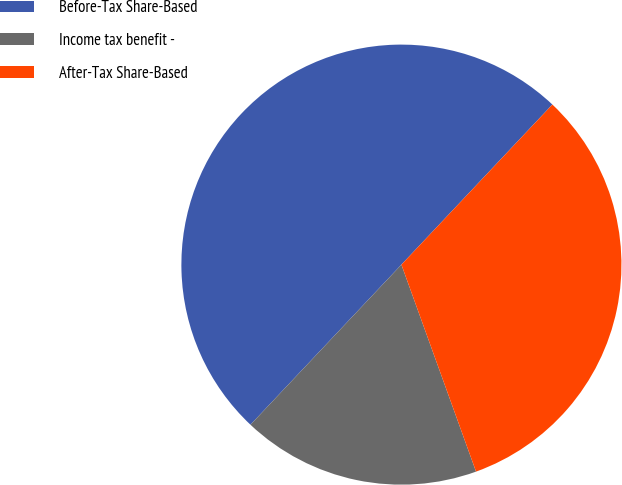Convert chart to OTSL. <chart><loc_0><loc_0><loc_500><loc_500><pie_chart><fcel>Before-Tax Share-Based<fcel>Income tax benefit -<fcel>After-Tax Share-Based<nl><fcel>50.0%<fcel>17.54%<fcel>32.46%<nl></chart> 